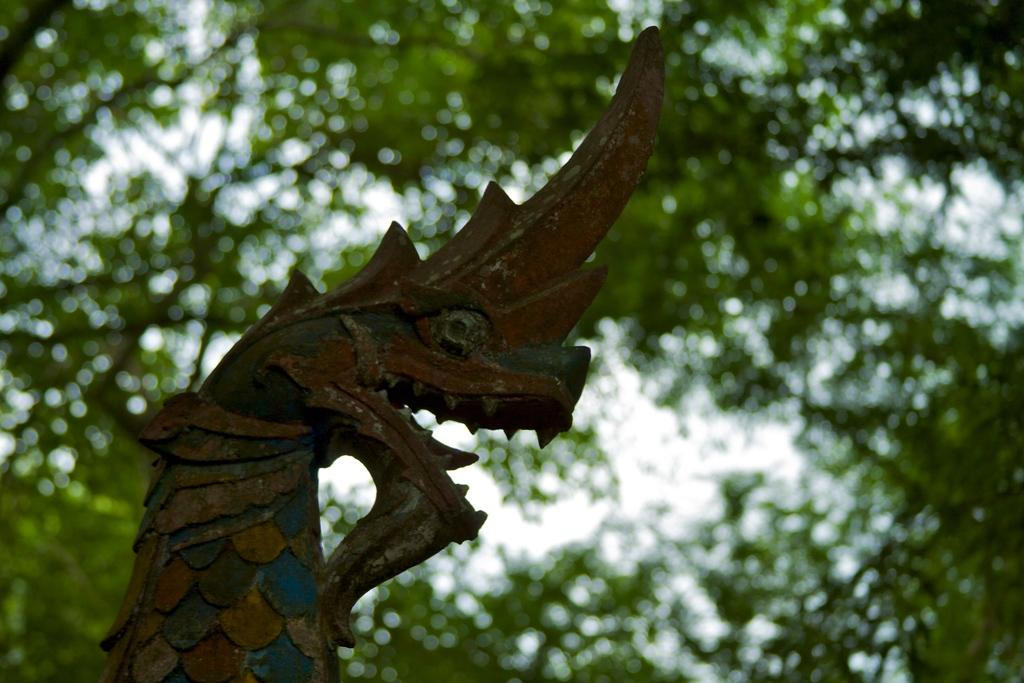What is the main subject of the image? The main subject of the image is a structure in the shape of a dragon. What colors are used for the dragon structure? The dragon structure is blue, yellow, and brown in color. What can be seen in the background of the image? There are trees and the sky visible in the background of the image. Can you tell me how many pins are holding the dragon structure together in the image? There is no mention of pins in the image, and therefore it is not possible to determine how many pins are holding the dragon structure together. 